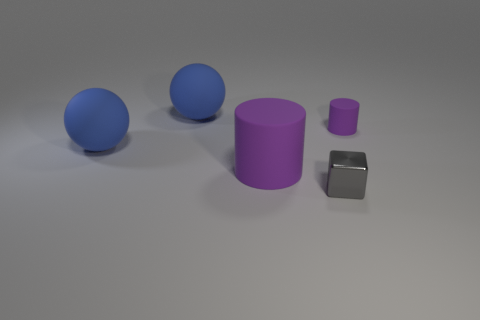Are the big cylinder and the tiny purple object made of the same material?
Your answer should be very brief. Yes. The object that is right of the large purple rubber object and to the left of the tiny rubber cylinder has what shape?
Ensure brevity in your answer.  Cube. Is there a cyan cylinder?
Your response must be concise. No. There is a large blue thing that is in front of the small matte object; is there a blue matte ball that is on the left side of it?
Keep it short and to the point. No. Is the number of metal things greater than the number of purple objects?
Keep it short and to the point. No. Is the color of the small matte thing the same as the rubber cylinder that is left of the cube?
Provide a short and direct response. Yes. There is a thing that is behind the big rubber cylinder and right of the big purple cylinder; what color is it?
Ensure brevity in your answer.  Purple. What number of other things are there of the same material as the small gray block
Give a very brief answer. 0. Is the number of things less than the number of shiny things?
Make the answer very short. No. Do the small purple object and the purple object left of the gray metallic object have the same material?
Your answer should be very brief. Yes. 